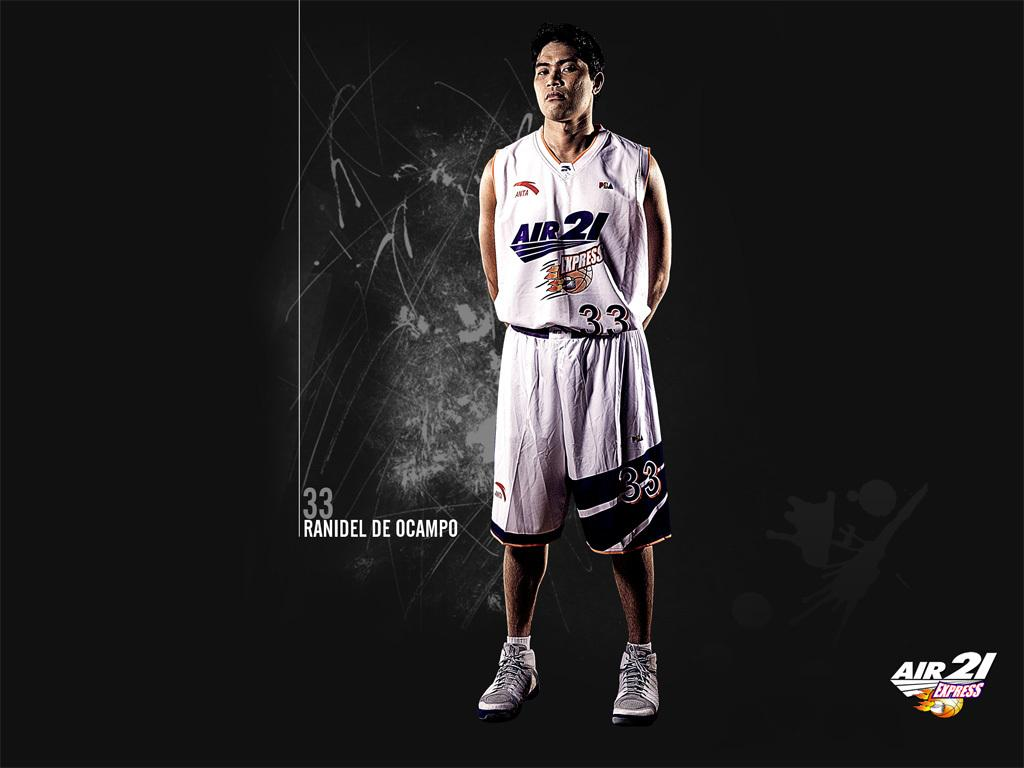<image>
Render a clear and concise summary of the photo. A man in an air 21 express basketball uniform. 